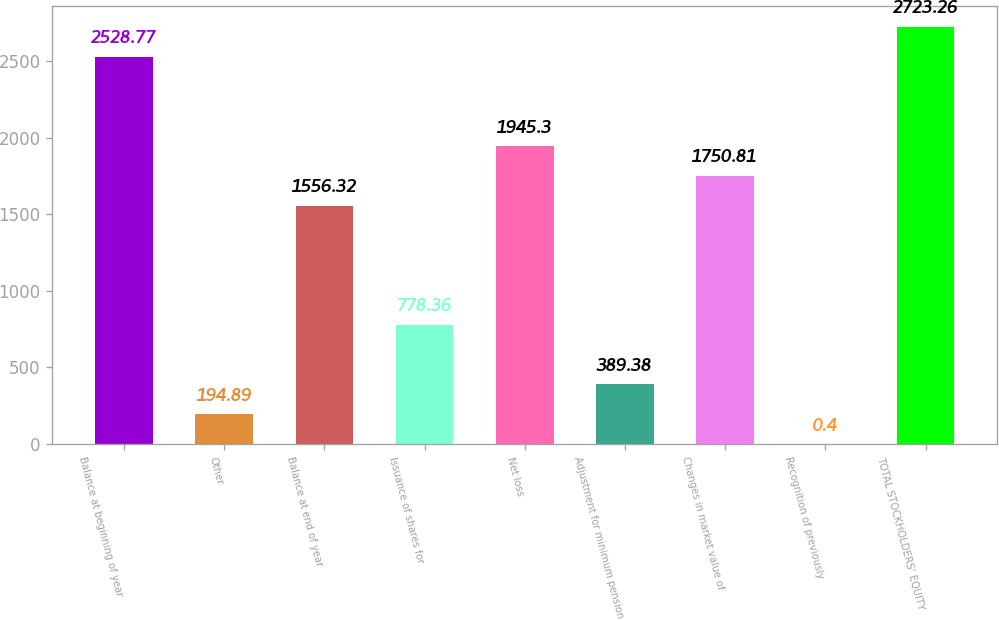Convert chart. <chart><loc_0><loc_0><loc_500><loc_500><bar_chart><fcel>Balance at beginning of year<fcel>Other<fcel>Balance at end of year<fcel>Issuance of shares for<fcel>Net loss<fcel>Adjustment for minimum pension<fcel>Changes in market value of<fcel>Recognition of previously<fcel>TOTAL STOCKHOLDERS' EQUITY<nl><fcel>2528.77<fcel>194.89<fcel>1556.32<fcel>778.36<fcel>1945.3<fcel>389.38<fcel>1750.81<fcel>0.4<fcel>2723.26<nl></chart> 